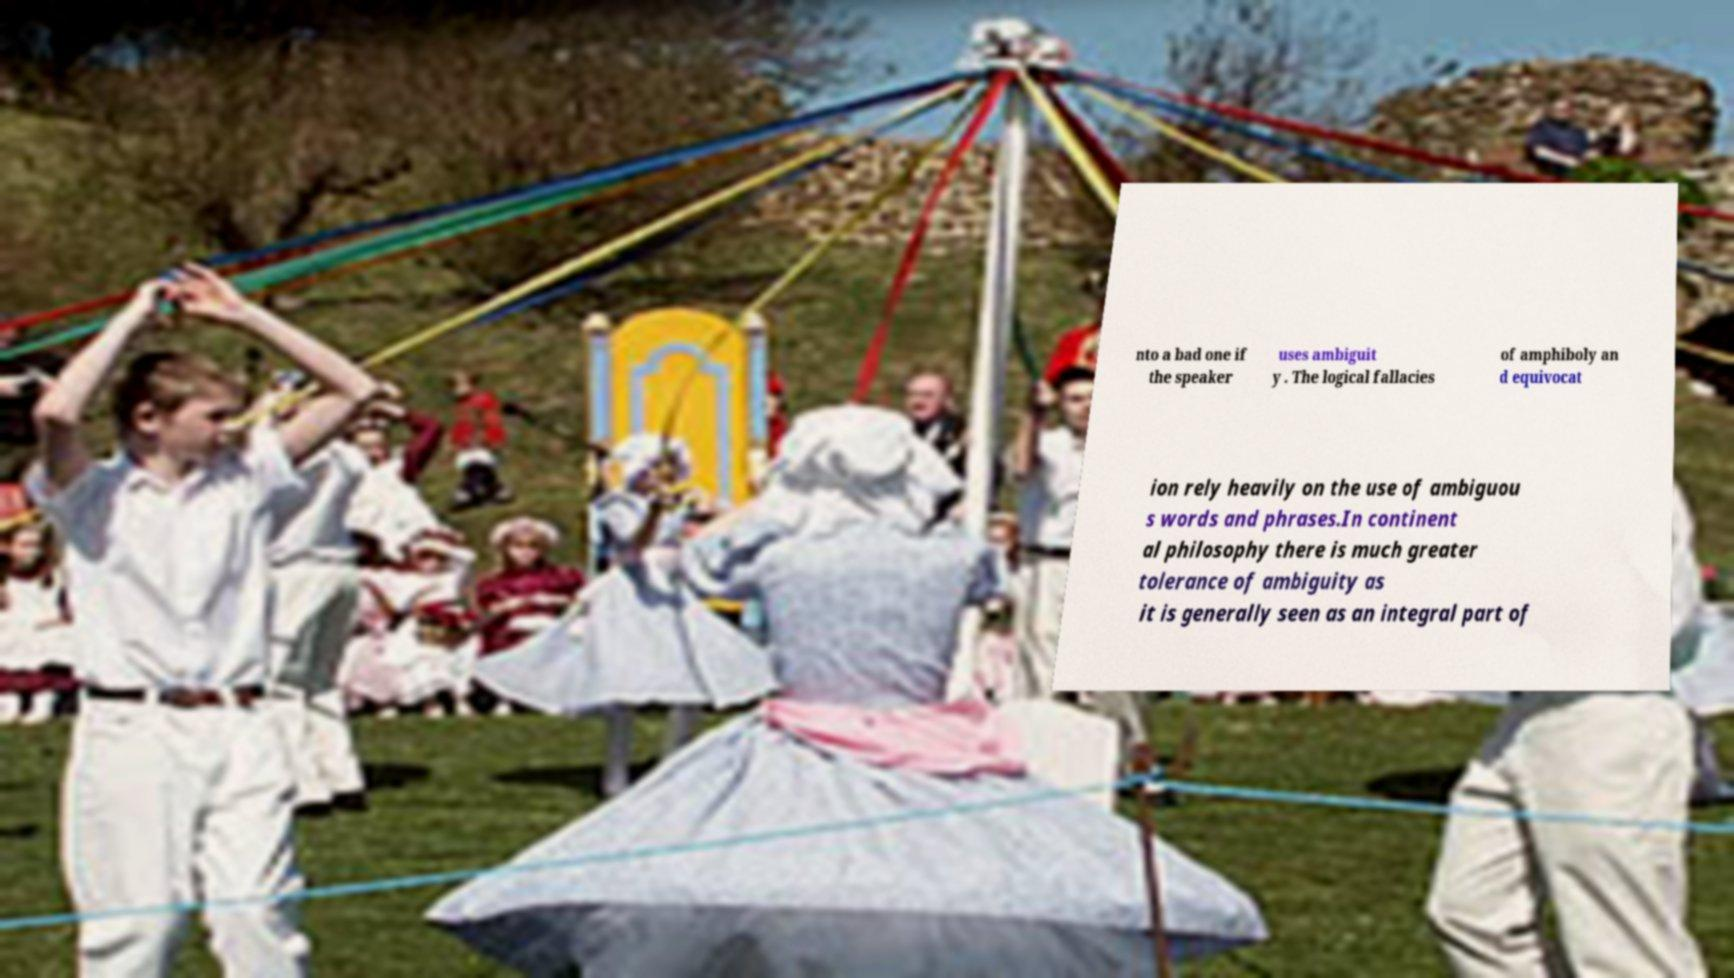There's text embedded in this image that I need extracted. Can you transcribe it verbatim? nto a bad one if the speaker uses ambiguit y . The logical fallacies of amphiboly an d equivocat ion rely heavily on the use of ambiguou s words and phrases.In continent al philosophy there is much greater tolerance of ambiguity as it is generally seen as an integral part of 